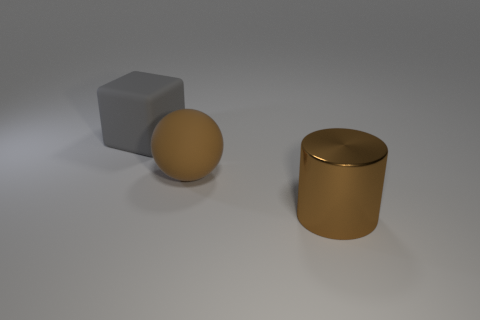Add 1 matte balls. How many objects exist? 4 Subtract all cubes. How many objects are left? 2 Add 3 yellow blocks. How many yellow blocks exist? 3 Subtract 0 yellow cubes. How many objects are left? 3 Subtract all large brown cylinders. Subtract all large gray rubber cubes. How many objects are left? 1 Add 2 gray matte blocks. How many gray matte blocks are left? 3 